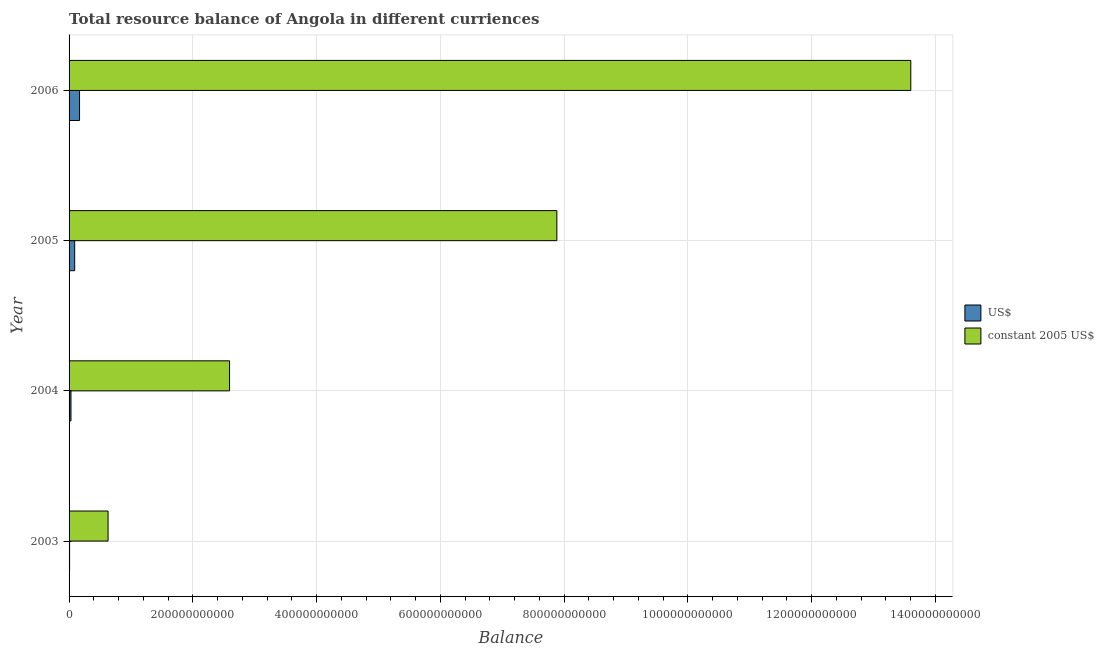How many groups of bars are there?
Offer a terse response. 4. Are the number of bars per tick equal to the number of legend labels?
Your response must be concise. Yes. How many bars are there on the 3rd tick from the bottom?
Your answer should be very brief. 2. What is the label of the 3rd group of bars from the top?
Make the answer very short. 2004. In how many cases, is the number of bars for a given year not equal to the number of legend labels?
Ensure brevity in your answer.  0. What is the resource balance in constant us$ in 2003?
Provide a succinct answer. 6.30e+1. Across all years, what is the maximum resource balance in us$?
Provide a short and direct response. 1.69e+1. Across all years, what is the minimum resource balance in constant us$?
Keep it short and to the point. 6.30e+1. In which year was the resource balance in us$ maximum?
Your response must be concise. 2006. In which year was the resource balance in constant us$ minimum?
Give a very brief answer. 2003. What is the total resource balance in us$ in the graph?
Your answer should be very brief. 2.99e+1. What is the difference between the resource balance in us$ in 2003 and that in 2005?
Give a very brief answer. -8.20e+09. What is the difference between the resource balance in constant us$ in 2003 and the resource balance in us$ in 2004?
Provide a succinct answer. 5.99e+1. What is the average resource balance in us$ per year?
Make the answer very short. 7.48e+09. In the year 2003, what is the difference between the resource balance in constant us$ and resource balance in us$?
Make the answer very short. 6.22e+1. What is the ratio of the resource balance in us$ in 2004 to that in 2006?
Offer a terse response. 0.18. Is the resource balance in constant us$ in 2004 less than that in 2005?
Ensure brevity in your answer.  Yes. Is the difference between the resource balance in constant us$ in 2005 and 2006 greater than the difference between the resource balance in us$ in 2005 and 2006?
Make the answer very short. No. What is the difference between the highest and the second highest resource balance in constant us$?
Give a very brief answer. 5.72e+11. What is the difference between the highest and the lowest resource balance in us$?
Your response must be concise. 1.61e+1. What does the 1st bar from the top in 2006 represents?
Make the answer very short. Constant 2005 us$. What does the 1st bar from the bottom in 2004 represents?
Your answer should be compact. US$. How many bars are there?
Your answer should be compact. 8. How many years are there in the graph?
Make the answer very short. 4. What is the difference between two consecutive major ticks on the X-axis?
Your answer should be compact. 2.00e+11. Are the values on the major ticks of X-axis written in scientific E-notation?
Give a very brief answer. No. Does the graph contain any zero values?
Your response must be concise. No. Does the graph contain grids?
Your answer should be compact. Yes. How are the legend labels stacked?
Give a very brief answer. Vertical. What is the title of the graph?
Make the answer very short. Total resource balance of Angola in different curriences. Does "Time to import" appear as one of the legend labels in the graph?
Provide a succinct answer. No. What is the label or title of the X-axis?
Ensure brevity in your answer.  Balance. What is the label or title of the Y-axis?
Offer a very short reply. Year. What is the Balance of US$ in 2003?
Your answer should be compact. 8.45e+08. What is the Balance in constant 2005 US$ in 2003?
Offer a terse response. 6.30e+1. What is the Balance of US$ in 2004?
Offer a terse response. 3.10e+09. What is the Balance of constant 2005 US$ in 2004?
Your answer should be very brief. 2.59e+11. What is the Balance in US$ in 2005?
Make the answer very short. 9.04e+09. What is the Balance of constant 2005 US$ in 2005?
Give a very brief answer. 7.88e+11. What is the Balance in US$ in 2006?
Offer a very short reply. 1.69e+1. What is the Balance of constant 2005 US$ in 2006?
Offer a very short reply. 1.36e+12. Across all years, what is the maximum Balance of US$?
Your answer should be compact. 1.69e+1. Across all years, what is the maximum Balance of constant 2005 US$?
Your answer should be very brief. 1.36e+12. Across all years, what is the minimum Balance in US$?
Your answer should be very brief. 8.45e+08. Across all years, what is the minimum Balance of constant 2005 US$?
Offer a very short reply. 6.30e+1. What is the total Balance of US$ in the graph?
Your response must be concise. 2.99e+1. What is the total Balance of constant 2005 US$ in the graph?
Your answer should be very brief. 2.47e+12. What is the difference between the Balance of US$ in 2003 and that in 2004?
Your answer should be compact. -2.26e+09. What is the difference between the Balance in constant 2005 US$ in 2003 and that in 2004?
Your answer should be very brief. -1.96e+11. What is the difference between the Balance of US$ in 2003 and that in 2005?
Provide a succinct answer. -8.20e+09. What is the difference between the Balance in constant 2005 US$ in 2003 and that in 2005?
Ensure brevity in your answer.  -7.25e+11. What is the difference between the Balance in US$ in 2003 and that in 2006?
Your answer should be very brief. -1.61e+1. What is the difference between the Balance of constant 2005 US$ in 2003 and that in 2006?
Keep it short and to the point. -1.30e+12. What is the difference between the Balance of US$ in 2004 and that in 2005?
Your response must be concise. -5.94e+09. What is the difference between the Balance in constant 2005 US$ in 2004 and that in 2005?
Your answer should be very brief. -5.29e+11. What is the difference between the Balance of US$ in 2004 and that in 2006?
Offer a very short reply. -1.38e+1. What is the difference between the Balance of constant 2005 US$ in 2004 and that in 2006?
Keep it short and to the point. -1.10e+12. What is the difference between the Balance of US$ in 2005 and that in 2006?
Your response must be concise. -7.88e+09. What is the difference between the Balance in constant 2005 US$ in 2005 and that in 2006?
Your response must be concise. -5.72e+11. What is the difference between the Balance in US$ in 2003 and the Balance in constant 2005 US$ in 2004?
Offer a terse response. -2.58e+11. What is the difference between the Balance of US$ in 2003 and the Balance of constant 2005 US$ in 2005?
Offer a terse response. -7.87e+11. What is the difference between the Balance of US$ in 2003 and the Balance of constant 2005 US$ in 2006?
Your answer should be compact. -1.36e+12. What is the difference between the Balance in US$ in 2004 and the Balance in constant 2005 US$ in 2005?
Your answer should be compact. -7.85e+11. What is the difference between the Balance of US$ in 2004 and the Balance of constant 2005 US$ in 2006?
Offer a very short reply. -1.36e+12. What is the difference between the Balance of US$ in 2005 and the Balance of constant 2005 US$ in 2006?
Give a very brief answer. -1.35e+12. What is the average Balance in US$ per year?
Keep it short and to the point. 7.48e+09. What is the average Balance of constant 2005 US$ per year?
Give a very brief answer. 6.18e+11. In the year 2003, what is the difference between the Balance of US$ and Balance of constant 2005 US$?
Make the answer very short. -6.22e+1. In the year 2004, what is the difference between the Balance in US$ and Balance in constant 2005 US$?
Ensure brevity in your answer.  -2.56e+11. In the year 2005, what is the difference between the Balance of US$ and Balance of constant 2005 US$?
Ensure brevity in your answer.  -7.79e+11. In the year 2006, what is the difference between the Balance of US$ and Balance of constant 2005 US$?
Offer a terse response. -1.34e+12. What is the ratio of the Balance of US$ in 2003 to that in 2004?
Provide a short and direct response. 0.27. What is the ratio of the Balance in constant 2005 US$ in 2003 to that in 2004?
Provide a short and direct response. 0.24. What is the ratio of the Balance in US$ in 2003 to that in 2005?
Ensure brevity in your answer.  0.09. What is the ratio of the Balance of constant 2005 US$ in 2003 to that in 2005?
Your answer should be very brief. 0.08. What is the ratio of the Balance of US$ in 2003 to that in 2006?
Offer a terse response. 0.05. What is the ratio of the Balance in constant 2005 US$ in 2003 to that in 2006?
Offer a terse response. 0.05. What is the ratio of the Balance in US$ in 2004 to that in 2005?
Offer a terse response. 0.34. What is the ratio of the Balance of constant 2005 US$ in 2004 to that in 2005?
Give a very brief answer. 0.33. What is the ratio of the Balance in US$ in 2004 to that in 2006?
Your answer should be very brief. 0.18. What is the ratio of the Balance in constant 2005 US$ in 2004 to that in 2006?
Offer a terse response. 0.19. What is the ratio of the Balance in US$ in 2005 to that in 2006?
Make the answer very short. 0.53. What is the ratio of the Balance in constant 2005 US$ in 2005 to that in 2006?
Provide a short and direct response. 0.58. What is the difference between the highest and the second highest Balance of US$?
Offer a very short reply. 7.88e+09. What is the difference between the highest and the second highest Balance in constant 2005 US$?
Offer a very short reply. 5.72e+11. What is the difference between the highest and the lowest Balance of US$?
Your response must be concise. 1.61e+1. What is the difference between the highest and the lowest Balance of constant 2005 US$?
Your answer should be very brief. 1.30e+12. 